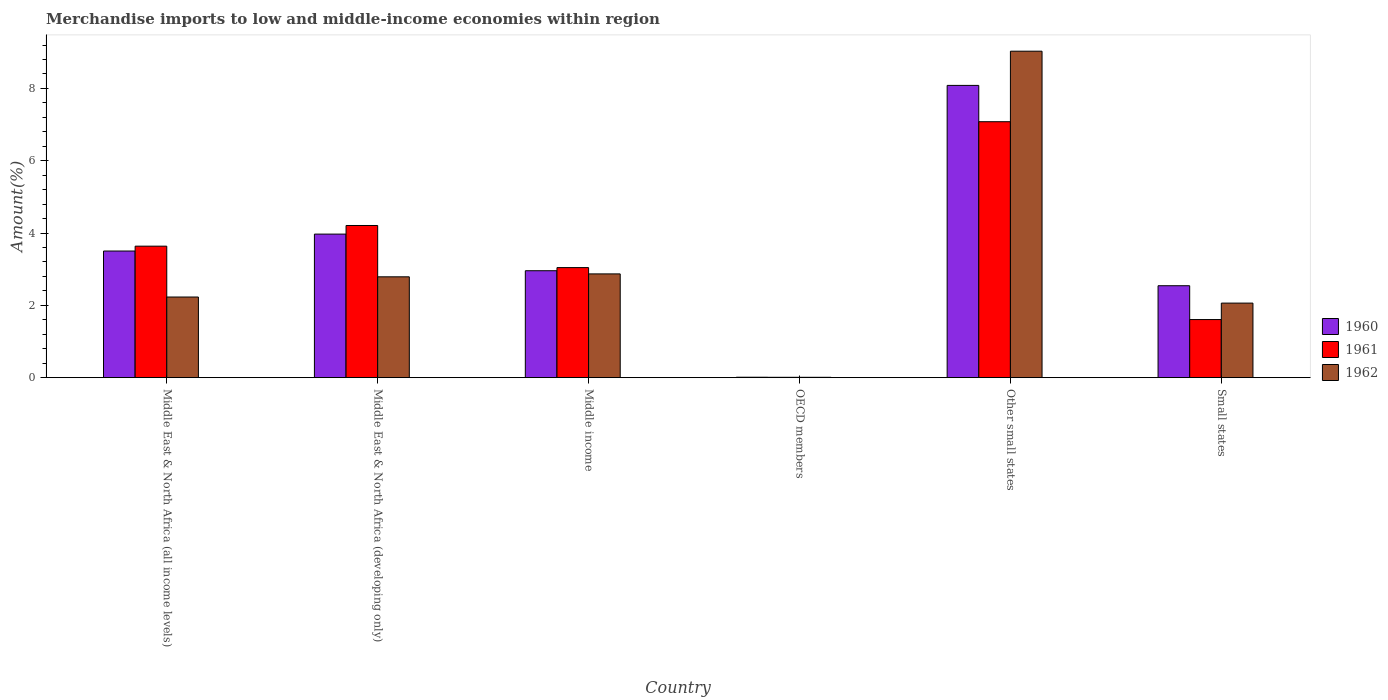How many groups of bars are there?
Give a very brief answer. 6. Are the number of bars on each tick of the X-axis equal?
Provide a short and direct response. Yes. How many bars are there on the 3rd tick from the right?
Keep it short and to the point. 3. What is the label of the 1st group of bars from the left?
Provide a short and direct response. Middle East & North Africa (all income levels). In how many cases, is the number of bars for a given country not equal to the number of legend labels?
Offer a terse response. 0. What is the percentage of amount earned from merchandise imports in 1961 in Small states?
Offer a terse response. 1.61. Across all countries, what is the maximum percentage of amount earned from merchandise imports in 1961?
Offer a very short reply. 7.08. Across all countries, what is the minimum percentage of amount earned from merchandise imports in 1960?
Provide a short and direct response. 0.01. In which country was the percentage of amount earned from merchandise imports in 1961 maximum?
Offer a very short reply. Other small states. What is the total percentage of amount earned from merchandise imports in 1962 in the graph?
Your response must be concise. 18.99. What is the difference between the percentage of amount earned from merchandise imports in 1960 in Middle income and that in OECD members?
Offer a terse response. 2.95. What is the difference between the percentage of amount earned from merchandise imports in 1961 in OECD members and the percentage of amount earned from merchandise imports in 1962 in Middle income?
Keep it short and to the point. -2.86. What is the average percentage of amount earned from merchandise imports in 1962 per country?
Provide a succinct answer. 3.17. What is the difference between the percentage of amount earned from merchandise imports of/in 1960 and percentage of amount earned from merchandise imports of/in 1962 in Small states?
Provide a short and direct response. 0.48. What is the ratio of the percentage of amount earned from merchandise imports in 1961 in Other small states to that in Small states?
Provide a succinct answer. 4.4. What is the difference between the highest and the second highest percentage of amount earned from merchandise imports in 1960?
Provide a short and direct response. 4.58. What is the difference between the highest and the lowest percentage of amount earned from merchandise imports in 1961?
Your answer should be compact. 7.07. In how many countries, is the percentage of amount earned from merchandise imports in 1960 greater than the average percentage of amount earned from merchandise imports in 1960 taken over all countries?
Ensure brevity in your answer.  2. What does the 2nd bar from the left in Other small states represents?
Offer a terse response. 1961. How many bars are there?
Ensure brevity in your answer.  18. Are all the bars in the graph horizontal?
Offer a very short reply. No. What is the difference between two consecutive major ticks on the Y-axis?
Your answer should be very brief. 2. Does the graph contain grids?
Offer a very short reply. No. How are the legend labels stacked?
Your answer should be compact. Vertical. What is the title of the graph?
Offer a terse response. Merchandise imports to low and middle-income economies within region. What is the label or title of the Y-axis?
Make the answer very short. Amount(%). What is the Amount(%) of 1960 in Middle East & North Africa (all income levels)?
Provide a short and direct response. 3.5. What is the Amount(%) in 1961 in Middle East & North Africa (all income levels)?
Your response must be concise. 3.64. What is the Amount(%) in 1962 in Middle East & North Africa (all income levels)?
Offer a terse response. 2.23. What is the Amount(%) of 1960 in Middle East & North Africa (developing only)?
Offer a very short reply. 3.97. What is the Amount(%) in 1961 in Middle East & North Africa (developing only)?
Provide a succinct answer. 4.21. What is the Amount(%) in 1962 in Middle East & North Africa (developing only)?
Your answer should be compact. 2.79. What is the Amount(%) in 1960 in Middle income?
Ensure brevity in your answer.  2.96. What is the Amount(%) in 1961 in Middle income?
Your answer should be very brief. 3.04. What is the Amount(%) in 1962 in Middle income?
Ensure brevity in your answer.  2.87. What is the Amount(%) of 1960 in OECD members?
Offer a terse response. 0.01. What is the Amount(%) in 1961 in OECD members?
Offer a terse response. 0.01. What is the Amount(%) of 1962 in OECD members?
Provide a short and direct response. 0.01. What is the Amount(%) of 1960 in Other small states?
Provide a succinct answer. 8.08. What is the Amount(%) in 1961 in Other small states?
Ensure brevity in your answer.  7.08. What is the Amount(%) in 1962 in Other small states?
Your answer should be compact. 9.03. What is the Amount(%) in 1960 in Small states?
Provide a succinct answer. 2.54. What is the Amount(%) of 1961 in Small states?
Your response must be concise. 1.61. What is the Amount(%) in 1962 in Small states?
Your answer should be compact. 2.06. Across all countries, what is the maximum Amount(%) in 1960?
Provide a succinct answer. 8.08. Across all countries, what is the maximum Amount(%) in 1961?
Give a very brief answer. 7.08. Across all countries, what is the maximum Amount(%) of 1962?
Keep it short and to the point. 9.03. Across all countries, what is the minimum Amount(%) in 1960?
Keep it short and to the point. 0.01. Across all countries, what is the minimum Amount(%) in 1961?
Ensure brevity in your answer.  0.01. Across all countries, what is the minimum Amount(%) of 1962?
Keep it short and to the point. 0.01. What is the total Amount(%) in 1960 in the graph?
Provide a short and direct response. 21.07. What is the total Amount(%) of 1961 in the graph?
Provide a short and direct response. 19.59. What is the total Amount(%) of 1962 in the graph?
Your answer should be very brief. 18.99. What is the difference between the Amount(%) of 1960 in Middle East & North Africa (all income levels) and that in Middle East & North Africa (developing only)?
Offer a terse response. -0.47. What is the difference between the Amount(%) of 1961 in Middle East & North Africa (all income levels) and that in Middle East & North Africa (developing only)?
Keep it short and to the point. -0.57. What is the difference between the Amount(%) in 1962 in Middle East & North Africa (all income levels) and that in Middle East & North Africa (developing only)?
Give a very brief answer. -0.56. What is the difference between the Amount(%) in 1960 in Middle East & North Africa (all income levels) and that in Middle income?
Ensure brevity in your answer.  0.55. What is the difference between the Amount(%) of 1961 in Middle East & North Africa (all income levels) and that in Middle income?
Provide a succinct answer. 0.59. What is the difference between the Amount(%) in 1962 in Middle East & North Africa (all income levels) and that in Middle income?
Provide a short and direct response. -0.64. What is the difference between the Amount(%) of 1960 in Middle East & North Africa (all income levels) and that in OECD members?
Offer a terse response. 3.49. What is the difference between the Amount(%) in 1961 in Middle East & North Africa (all income levels) and that in OECD members?
Your answer should be very brief. 3.63. What is the difference between the Amount(%) in 1962 in Middle East & North Africa (all income levels) and that in OECD members?
Provide a succinct answer. 2.22. What is the difference between the Amount(%) of 1960 in Middle East & North Africa (all income levels) and that in Other small states?
Make the answer very short. -4.58. What is the difference between the Amount(%) of 1961 in Middle East & North Africa (all income levels) and that in Other small states?
Keep it short and to the point. -3.44. What is the difference between the Amount(%) of 1962 in Middle East & North Africa (all income levels) and that in Other small states?
Provide a short and direct response. -6.8. What is the difference between the Amount(%) in 1960 in Middle East & North Africa (all income levels) and that in Small states?
Offer a very short reply. 0.96. What is the difference between the Amount(%) of 1961 in Middle East & North Africa (all income levels) and that in Small states?
Give a very brief answer. 2.03. What is the difference between the Amount(%) of 1962 in Middle East & North Africa (all income levels) and that in Small states?
Give a very brief answer. 0.17. What is the difference between the Amount(%) of 1960 in Middle East & North Africa (developing only) and that in Middle income?
Make the answer very short. 1.01. What is the difference between the Amount(%) in 1961 in Middle East & North Africa (developing only) and that in Middle income?
Provide a short and direct response. 1.16. What is the difference between the Amount(%) of 1962 in Middle East & North Africa (developing only) and that in Middle income?
Make the answer very short. -0.08. What is the difference between the Amount(%) of 1960 in Middle East & North Africa (developing only) and that in OECD members?
Provide a short and direct response. 3.96. What is the difference between the Amount(%) in 1961 in Middle East & North Africa (developing only) and that in OECD members?
Your answer should be compact. 4.2. What is the difference between the Amount(%) in 1962 in Middle East & North Africa (developing only) and that in OECD members?
Offer a terse response. 2.78. What is the difference between the Amount(%) of 1960 in Middle East & North Africa (developing only) and that in Other small states?
Provide a succinct answer. -4.11. What is the difference between the Amount(%) in 1961 in Middle East & North Africa (developing only) and that in Other small states?
Keep it short and to the point. -2.87. What is the difference between the Amount(%) of 1962 in Middle East & North Africa (developing only) and that in Other small states?
Provide a succinct answer. -6.24. What is the difference between the Amount(%) of 1960 in Middle East & North Africa (developing only) and that in Small states?
Provide a succinct answer. 1.43. What is the difference between the Amount(%) in 1961 in Middle East & North Africa (developing only) and that in Small states?
Your answer should be very brief. 2.6. What is the difference between the Amount(%) in 1962 in Middle East & North Africa (developing only) and that in Small states?
Your answer should be compact. 0.73. What is the difference between the Amount(%) in 1960 in Middle income and that in OECD members?
Provide a short and direct response. 2.95. What is the difference between the Amount(%) of 1961 in Middle income and that in OECD members?
Keep it short and to the point. 3.03. What is the difference between the Amount(%) in 1962 in Middle income and that in OECD members?
Provide a short and direct response. 2.86. What is the difference between the Amount(%) in 1960 in Middle income and that in Other small states?
Provide a succinct answer. -5.13. What is the difference between the Amount(%) of 1961 in Middle income and that in Other small states?
Your answer should be compact. -4.04. What is the difference between the Amount(%) of 1962 in Middle income and that in Other small states?
Offer a very short reply. -6.16. What is the difference between the Amount(%) in 1960 in Middle income and that in Small states?
Give a very brief answer. 0.41. What is the difference between the Amount(%) in 1961 in Middle income and that in Small states?
Your response must be concise. 1.44. What is the difference between the Amount(%) in 1962 in Middle income and that in Small states?
Give a very brief answer. 0.81. What is the difference between the Amount(%) in 1960 in OECD members and that in Other small states?
Make the answer very short. -8.07. What is the difference between the Amount(%) in 1961 in OECD members and that in Other small states?
Your answer should be very brief. -7.07. What is the difference between the Amount(%) of 1962 in OECD members and that in Other small states?
Provide a succinct answer. -9.02. What is the difference between the Amount(%) in 1960 in OECD members and that in Small states?
Your answer should be compact. -2.53. What is the difference between the Amount(%) of 1961 in OECD members and that in Small states?
Your answer should be compact. -1.6. What is the difference between the Amount(%) in 1962 in OECD members and that in Small states?
Offer a very short reply. -2.05. What is the difference between the Amount(%) of 1960 in Other small states and that in Small states?
Your answer should be compact. 5.54. What is the difference between the Amount(%) in 1961 in Other small states and that in Small states?
Offer a very short reply. 5.47. What is the difference between the Amount(%) of 1962 in Other small states and that in Small states?
Make the answer very short. 6.97. What is the difference between the Amount(%) of 1960 in Middle East & North Africa (all income levels) and the Amount(%) of 1961 in Middle East & North Africa (developing only)?
Ensure brevity in your answer.  -0.71. What is the difference between the Amount(%) in 1960 in Middle East & North Africa (all income levels) and the Amount(%) in 1962 in Middle East & North Africa (developing only)?
Offer a very short reply. 0.71. What is the difference between the Amount(%) of 1961 in Middle East & North Africa (all income levels) and the Amount(%) of 1962 in Middle East & North Africa (developing only)?
Your response must be concise. 0.85. What is the difference between the Amount(%) in 1960 in Middle East & North Africa (all income levels) and the Amount(%) in 1961 in Middle income?
Keep it short and to the point. 0.46. What is the difference between the Amount(%) in 1960 in Middle East & North Africa (all income levels) and the Amount(%) in 1962 in Middle income?
Your answer should be compact. 0.63. What is the difference between the Amount(%) in 1961 in Middle East & North Africa (all income levels) and the Amount(%) in 1962 in Middle income?
Ensure brevity in your answer.  0.77. What is the difference between the Amount(%) in 1960 in Middle East & North Africa (all income levels) and the Amount(%) in 1961 in OECD members?
Your response must be concise. 3.49. What is the difference between the Amount(%) of 1960 in Middle East & North Africa (all income levels) and the Amount(%) of 1962 in OECD members?
Your response must be concise. 3.49. What is the difference between the Amount(%) in 1961 in Middle East & North Africa (all income levels) and the Amount(%) in 1962 in OECD members?
Offer a very short reply. 3.63. What is the difference between the Amount(%) of 1960 in Middle East & North Africa (all income levels) and the Amount(%) of 1961 in Other small states?
Keep it short and to the point. -3.58. What is the difference between the Amount(%) of 1960 in Middle East & North Africa (all income levels) and the Amount(%) of 1962 in Other small states?
Your response must be concise. -5.53. What is the difference between the Amount(%) in 1961 in Middle East & North Africa (all income levels) and the Amount(%) in 1962 in Other small states?
Provide a short and direct response. -5.39. What is the difference between the Amount(%) of 1960 in Middle East & North Africa (all income levels) and the Amount(%) of 1961 in Small states?
Offer a very short reply. 1.9. What is the difference between the Amount(%) of 1960 in Middle East & North Africa (all income levels) and the Amount(%) of 1962 in Small states?
Offer a terse response. 1.44. What is the difference between the Amount(%) in 1961 in Middle East & North Africa (all income levels) and the Amount(%) in 1962 in Small states?
Your response must be concise. 1.57. What is the difference between the Amount(%) in 1960 in Middle East & North Africa (developing only) and the Amount(%) in 1961 in Middle income?
Your answer should be compact. 0.93. What is the difference between the Amount(%) of 1960 in Middle East & North Africa (developing only) and the Amount(%) of 1962 in Middle income?
Your answer should be compact. 1.1. What is the difference between the Amount(%) in 1961 in Middle East & North Africa (developing only) and the Amount(%) in 1962 in Middle income?
Your answer should be compact. 1.34. What is the difference between the Amount(%) in 1960 in Middle East & North Africa (developing only) and the Amount(%) in 1961 in OECD members?
Provide a succinct answer. 3.96. What is the difference between the Amount(%) of 1960 in Middle East & North Africa (developing only) and the Amount(%) of 1962 in OECD members?
Give a very brief answer. 3.96. What is the difference between the Amount(%) of 1961 in Middle East & North Africa (developing only) and the Amount(%) of 1962 in OECD members?
Your response must be concise. 4.2. What is the difference between the Amount(%) of 1960 in Middle East & North Africa (developing only) and the Amount(%) of 1961 in Other small states?
Your answer should be compact. -3.11. What is the difference between the Amount(%) of 1960 in Middle East & North Africa (developing only) and the Amount(%) of 1962 in Other small states?
Keep it short and to the point. -5.06. What is the difference between the Amount(%) of 1961 in Middle East & North Africa (developing only) and the Amount(%) of 1962 in Other small states?
Make the answer very short. -4.82. What is the difference between the Amount(%) in 1960 in Middle East & North Africa (developing only) and the Amount(%) in 1961 in Small states?
Offer a very short reply. 2.36. What is the difference between the Amount(%) in 1960 in Middle East & North Africa (developing only) and the Amount(%) in 1962 in Small states?
Offer a terse response. 1.91. What is the difference between the Amount(%) of 1961 in Middle East & North Africa (developing only) and the Amount(%) of 1962 in Small states?
Your response must be concise. 2.15. What is the difference between the Amount(%) of 1960 in Middle income and the Amount(%) of 1961 in OECD members?
Your answer should be compact. 2.95. What is the difference between the Amount(%) of 1960 in Middle income and the Amount(%) of 1962 in OECD members?
Provide a succinct answer. 2.95. What is the difference between the Amount(%) in 1961 in Middle income and the Amount(%) in 1962 in OECD members?
Provide a succinct answer. 3.03. What is the difference between the Amount(%) in 1960 in Middle income and the Amount(%) in 1961 in Other small states?
Offer a very short reply. -4.12. What is the difference between the Amount(%) of 1960 in Middle income and the Amount(%) of 1962 in Other small states?
Your response must be concise. -6.07. What is the difference between the Amount(%) in 1961 in Middle income and the Amount(%) in 1962 in Other small states?
Keep it short and to the point. -5.99. What is the difference between the Amount(%) in 1960 in Middle income and the Amount(%) in 1961 in Small states?
Provide a succinct answer. 1.35. What is the difference between the Amount(%) in 1960 in Middle income and the Amount(%) in 1962 in Small states?
Ensure brevity in your answer.  0.9. What is the difference between the Amount(%) in 1961 in Middle income and the Amount(%) in 1962 in Small states?
Keep it short and to the point. 0.98. What is the difference between the Amount(%) in 1960 in OECD members and the Amount(%) in 1961 in Other small states?
Offer a terse response. -7.07. What is the difference between the Amount(%) of 1960 in OECD members and the Amount(%) of 1962 in Other small states?
Your response must be concise. -9.02. What is the difference between the Amount(%) in 1961 in OECD members and the Amount(%) in 1962 in Other small states?
Provide a succinct answer. -9.02. What is the difference between the Amount(%) of 1960 in OECD members and the Amount(%) of 1961 in Small states?
Your answer should be very brief. -1.59. What is the difference between the Amount(%) of 1960 in OECD members and the Amount(%) of 1962 in Small states?
Your answer should be compact. -2.05. What is the difference between the Amount(%) of 1961 in OECD members and the Amount(%) of 1962 in Small states?
Your answer should be compact. -2.05. What is the difference between the Amount(%) of 1960 in Other small states and the Amount(%) of 1961 in Small states?
Offer a very short reply. 6.48. What is the difference between the Amount(%) of 1960 in Other small states and the Amount(%) of 1962 in Small states?
Offer a very short reply. 6.02. What is the difference between the Amount(%) in 1961 in Other small states and the Amount(%) in 1962 in Small states?
Your response must be concise. 5.02. What is the average Amount(%) of 1960 per country?
Offer a terse response. 3.51. What is the average Amount(%) in 1961 per country?
Provide a short and direct response. 3.26. What is the average Amount(%) of 1962 per country?
Your answer should be very brief. 3.17. What is the difference between the Amount(%) in 1960 and Amount(%) in 1961 in Middle East & North Africa (all income levels)?
Provide a succinct answer. -0.13. What is the difference between the Amount(%) of 1960 and Amount(%) of 1962 in Middle East & North Africa (all income levels)?
Provide a short and direct response. 1.27. What is the difference between the Amount(%) in 1961 and Amount(%) in 1962 in Middle East & North Africa (all income levels)?
Offer a terse response. 1.41. What is the difference between the Amount(%) in 1960 and Amount(%) in 1961 in Middle East & North Africa (developing only)?
Your answer should be very brief. -0.24. What is the difference between the Amount(%) in 1960 and Amount(%) in 1962 in Middle East & North Africa (developing only)?
Your answer should be compact. 1.18. What is the difference between the Amount(%) of 1961 and Amount(%) of 1962 in Middle East & North Africa (developing only)?
Your answer should be very brief. 1.42. What is the difference between the Amount(%) of 1960 and Amount(%) of 1961 in Middle income?
Keep it short and to the point. -0.09. What is the difference between the Amount(%) of 1960 and Amount(%) of 1962 in Middle income?
Offer a very short reply. 0.09. What is the difference between the Amount(%) in 1961 and Amount(%) in 1962 in Middle income?
Provide a succinct answer. 0.17. What is the difference between the Amount(%) of 1960 and Amount(%) of 1961 in OECD members?
Give a very brief answer. 0. What is the difference between the Amount(%) of 1960 and Amount(%) of 1962 in OECD members?
Offer a very short reply. 0. What is the difference between the Amount(%) of 1960 and Amount(%) of 1961 in Other small states?
Offer a very short reply. 1. What is the difference between the Amount(%) of 1960 and Amount(%) of 1962 in Other small states?
Your answer should be compact. -0.95. What is the difference between the Amount(%) of 1961 and Amount(%) of 1962 in Other small states?
Make the answer very short. -1.95. What is the difference between the Amount(%) of 1960 and Amount(%) of 1961 in Small states?
Give a very brief answer. 0.94. What is the difference between the Amount(%) in 1960 and Amount(%) in 1962 in Small states?
Provide a short and direct response. 0.48. What is the difference between the Amount(%) in 1961 and Amount(%) in 1962 in Small states?
Your response must be concise. -0.46. What is the ratio of the Amount(%) in 1960 in Middle East & North Africa (all income levels) to that in Middle East & North Africa (developing only)?
Your answer should be compact. 0.88. What is the ratio of the Amount(%) of 1961 in Middle East & North Africa (all income levels) to that in Middle East & North Africa (developing only)?
Your response must be concise. 0.86. What is the ratio of the Amount(%) of 1962 in Middle East & North Africa (all income levels) to that in Middle East & North Africa (developing only)?
Ensure brevity in your answer.  0.8. What is the ratio of the Amount(%) in 1960 in Middle East & North Africa (all income levels) to that in Middle income?
Your response must be concise. 1.18. What is the ratio of the Amount(%) of 1961 in Middle East & North Africa (all income levels) to that in Middle income?
Offer a very short reply. 1.19. What is the ratio of the Amount(%) of 1962 in Middle East & North Africa (all income levels) to that in Middle income?
Your answer should be very brief. 0.78. What is the ratio of the Amount(%) of 1960 in Middle East & North Africa (all income levels) to that in OECD members?
Your answer should be very brief. 284.87. What is the ratio of the Amount(%) of 1961 in Middle East & North Africa (all income levels) to that in OECD members?
Your answer should be compact. 359.78. What is the ratio of the Amount(%) of 1962 in Middle East & North Africa (all income levels) to that in OECD members?
Give a very brief answer. 222.44. What is the ratio of the Amount(%) in 1960 in Middle East & North Africa (all income levels) to that in Other small states?
Offer a very short reply. 0.43. What is the ratio of the Amount(%) of 1961 in Middle East & North Africa (all income levels) to that in Other small states?
Make the answer very short. 0.51. What is the ratio of the Amount(%) in 1962 in Middle East & North Africa (all income levels) to that in Other small states?
Keep it short and to the point. 0.25. What is the ratio of the Amount(%) of 1960 in Middle East & North Africa (all income levels) to that in Small states?
Provide a succinct answer. 1.38. What is the ratio of the Amount(%) of 1961 in Middle East & North Africa (all income levels) to that in Small states?
Provide a succinct answer. 2.26. What is the ratio of the Amount(%) in 1962 in Middle East & North Africa (all income levels) to that in Small states?
Make the answer very short. 1.08. What is the ratio of the Amount(%) of 1960 in Middle East & North Africa (developing only) to that in Middle income?
Make the answer very short. 1.34. What is the ratio of the Amount(%) in 1961 in Middle East & North Africa (developing only) to that in Middle income?
Your response must be concise. 1.38. What is the ratio of the Amount(%) of 1962 in Middle East & North Africa (developing only) to that in Middle income?
Offer a terse response. 0.97. What is the ratio of the Amount(%) of 1960 in Middle East & North Africa (developing only) to that in OECD members?
Make the answer very short. 322.95. What is the ratio of the Amount(%) in 1961 in Middle East & North Africa (developing only) to that in OECD members?
Keep it short and to the point. 416.33. What is the ratio of the Amount(%) of 1962 in Middle East & North Africa (developing only) to that in OECD members?
Your response must be concise. 278.2. What is the ratio of the Amount(%) of 1960 in Middle East & North Africa (developing only) to that in Other small states?
Ensure brevity in your answer.  0.49. What is the ratio of the Amount(%) in 1961 in Middle East & North Africa (developing only) to that in Other small states?
Give a very brief answer. 0.59. What is the ratio of the Amount(%) in 1962 in Middle East & North Africa (developing only) to that in Other small states?
Offer a very short reply. 0.31. What is the ratio of the Amount(%) of 1960 in Middle East & North Africa (developing only) to that in Small states?
Your answer should be compact. 1.56. What is the ratio of the Amount(%) of 1961 in Middle East & North Africa (developing only) to that in Small states?
Provide a succinct answer. 2.62. What is the ratio of the Amount(%) in 1962 in Middle East & North Africa (developing only) to that in Small states?
Your answer should be compact. 1.35. What is the ratio of the Amount(%) of 1960 in Middle income to that in OECD members?
Your response must be concise. 240.54. What is the ratio of the Amount(%) of 1961 in Middle income to that in OECD members?
Provide a short and direct response. 301.11. What is the ratio of the Amount(%) in 1962 in Middle income to that in OECD members?
Your answer should be very brief. 286.23. What is the ratio of the Amount(%) of 1960 in Middle income to that in Other small states?
Provide a succinct answer. 0.37. What is the ratio of the Amount(%) in 1961 in Middle income to that in Other small states?
Make the answer very short. 0.43. What is the ratio of the Amount(%) in 1962 in Middle income to that in Other small states?
Ensure brevity in your answer.  0.32. What is the ratio of the Amount(%) of 1960 in Middle income to that in Small states?
Provide a succinct answer. 1.16. What is the ratio of the Amount(%) of 1961 in Middle income to that in Small states?
Provide a short and direct response. 1.89. What is the ratio of the Amount(%) in 1962 in Middle income to that in Small states?
Your answer should be very brief. 1.39. What is the ratio of the Amount(%) in 1960 in OECD members to that in Other small states?
Give a very brief answer. 0. What is the ratio of the Amount(%) of 1961 in OECD members to that in Other small states?
Ensure brevity in your answer.  0. What is the ratio of the Amount(%) of 1962 in OECD members to that in Other small states?
Keep it short and to the point. 0. What is the ratio of the Amount(%) of 1960 in OECD members to that in Small states?
Give a very brief answer. 0. What is the ratio of the Amount(%) of 1961 in OECD members to that in Small states?
Ensure brevity in your answer.  0.01. What is the ratio of the Amount(%) in 1962 in OECD members to that in Small states?
Keep it short and to the point. 0. What is the ratio of the Amount(%) in 1960 in Other small states to that in Small states?
Your response must be concise. 3.18. What is the ratio of the Amount(%) in 1961 in Other small states to that in Small states?
Make the answer very short. 4.4. What is the ratio of the Amount(%) of 1962 in Other small states to that in Small states?
Ensure brevity in your answer.  4.38. What is the difference between the highest and the second highest Amount(%) in 1960?
Your answer should be very brief. 4.11. What is the difference between the highest and the second highest Amount(%) in 1961?
Your response must be concise. 2.87. What is the difference between the highest and the second highest Amount(%) of 1962?
Provide a short and direct response. 6.16. What is the difference between the highest and the lowest Amount(%) of 1960?
Offer a very short reply. 8.07. What is the difference between the highest and the lowest Amount(%) of 1961?
Your response must be concise. 7.07. What is the difference between the highest and the lowest Amount(%) in 1962?
Your answer should be compact. 9.02. 